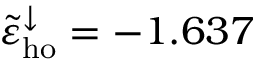Convert formula to latex. <formula><loc_0><loc_0><loc_500><loc_500>\tilde { \varepsilon } _ { h o } ^ { \downarrow } = - 1 . 6 3 7</formula> 